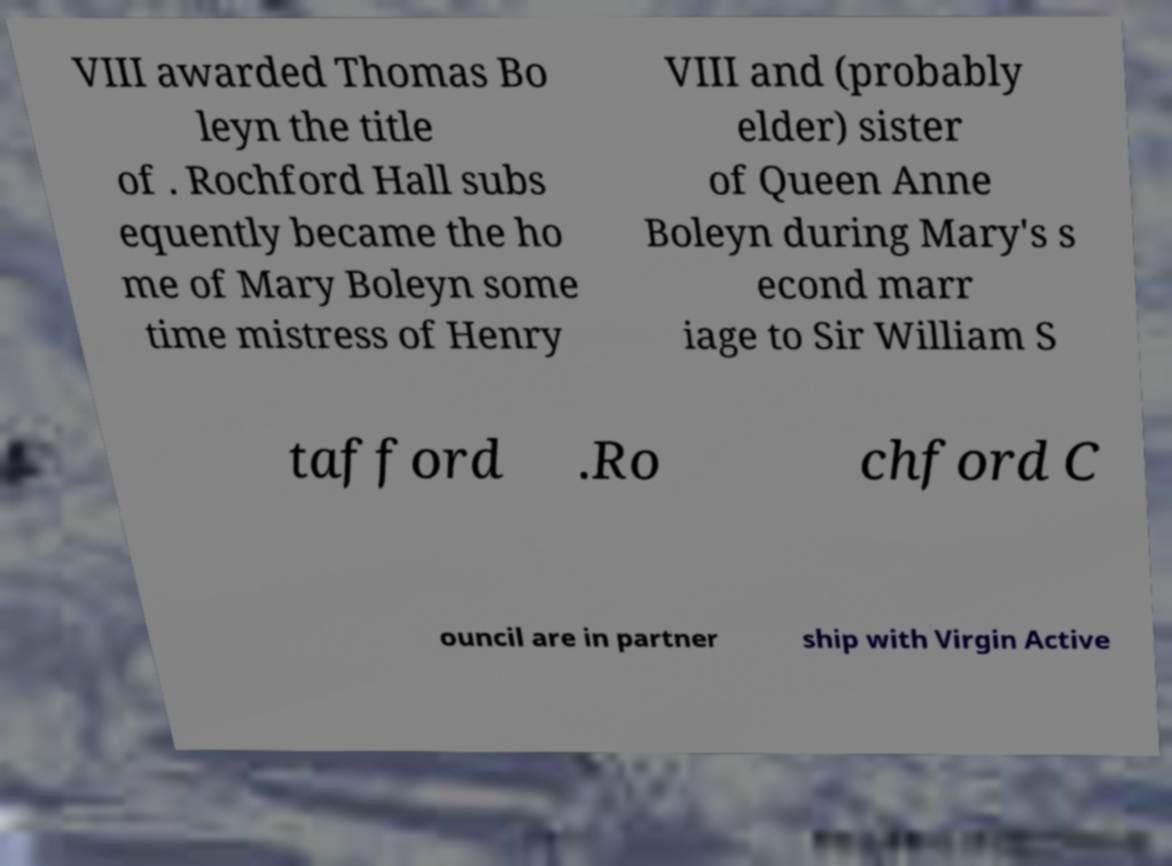Please read and relay the text visible in this image. What does it say? VIII awarded Thomas Bo leyn the title of . Rochford Hall subs equently became the ho me of Mary Boleyn some time mistress of Henry VIII and (probably elder) sister of Queen Anne Boleyn during Mary's s econd marr iage to Sir William S tafford .Ro chford C ouncil are in partner ship with Virgin Active 